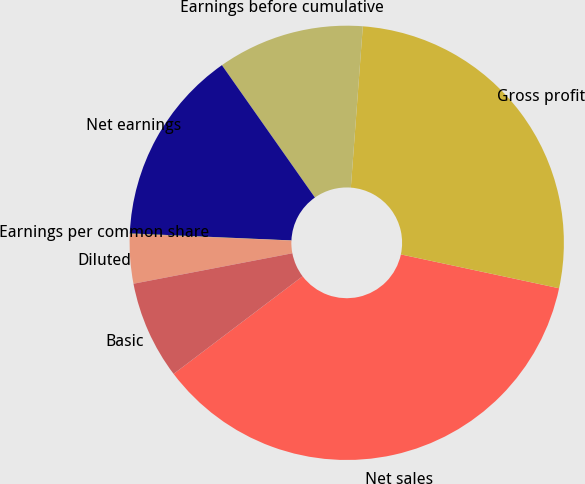Convert chart to OTSL. <chart><loc_0><loc_0><loc_500><loc_500><pie_chart><fcel>Net sales<fcel>Gross profit<fcel>Earnings before cumulative<fcel>Net earnings<fcel>Earnings per common share<fcel>Diluted<fcel>Basic<nl><fcel>36.34%<fcel>27.18%<fcel>10.93%<fcel>14.56%<fcel>0.04%<fcel>3.67%<fcel>7.3%<nl></chart> 